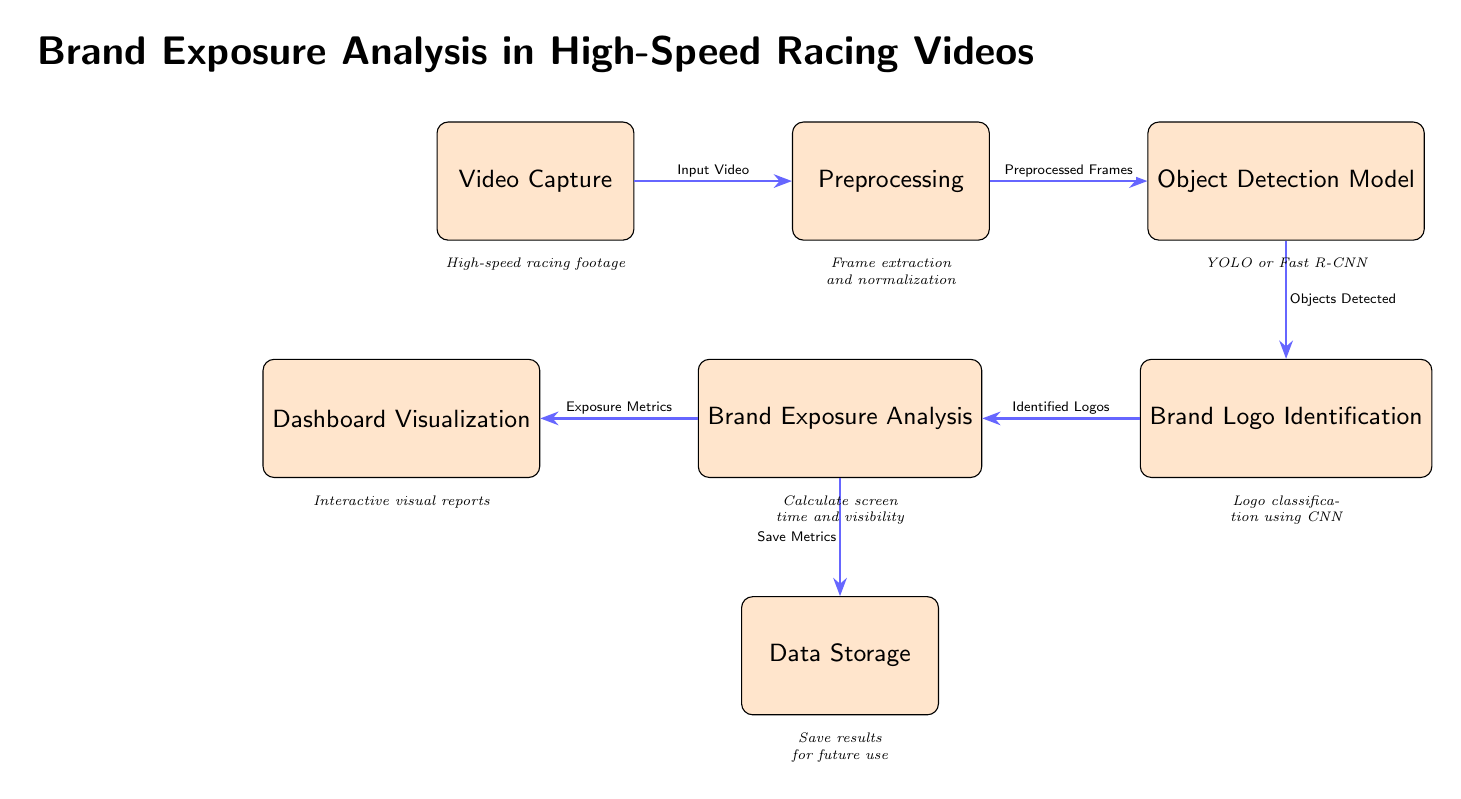What is the first step in the process? The first step in the process shown in the diagram is "Video Capture," which is represented as the topmost node.
Answer: Video Capture How many total nodes are in the diagram? The diagram contains seven nodes, each representing a distinct step in the brand exposure analysis process.
Answer: Seven What type of model is used for object detection? The object detection model indicated in the diagram is either "YOLO or Fast R-CNN," which are popular frameworks for detecting objects within images.
Answer: YOLO or Fast R-CNN What does the object detection model output? The output of the object detection model, according to the diagram, includes "Objects Detected," which refers to the visual elements identified in the video frames.
Answer: Objects Detected What is analyzed after brand logo identification? After brand logo identification, the next step is "Brand Exposure Analysis," where metrics related to the logos identified are calculated.
Answer: Brand Exposure Analysis Which node stores results for future use? The node responsible for storing results is "Data Storage," which highlights the importance of keeping the analyzed data for later reference.
Answer: Data Storage What type of reports are generated in the visualization step? The visualization step generates "Interactive visual reports," which are tools for displaying the exposure metrics and insights derived from the analysis.
Answer: Interactive visual reports How are exposure metrics transferred in the process? Exposure metrics are transferred from "Brand Exposure Analysis" to "Dashboard Visualization," indicating the flow of processed information towards visual representation.
Answer: Dashboard Visualization Which processes precede the logo identification? The processes that precede logo identification are "Preprocessing" and "Object Detection Model," indicating a necessary sequence of steps before logos can be categorized.
Answer: Preprocessing and Object Detection Model 